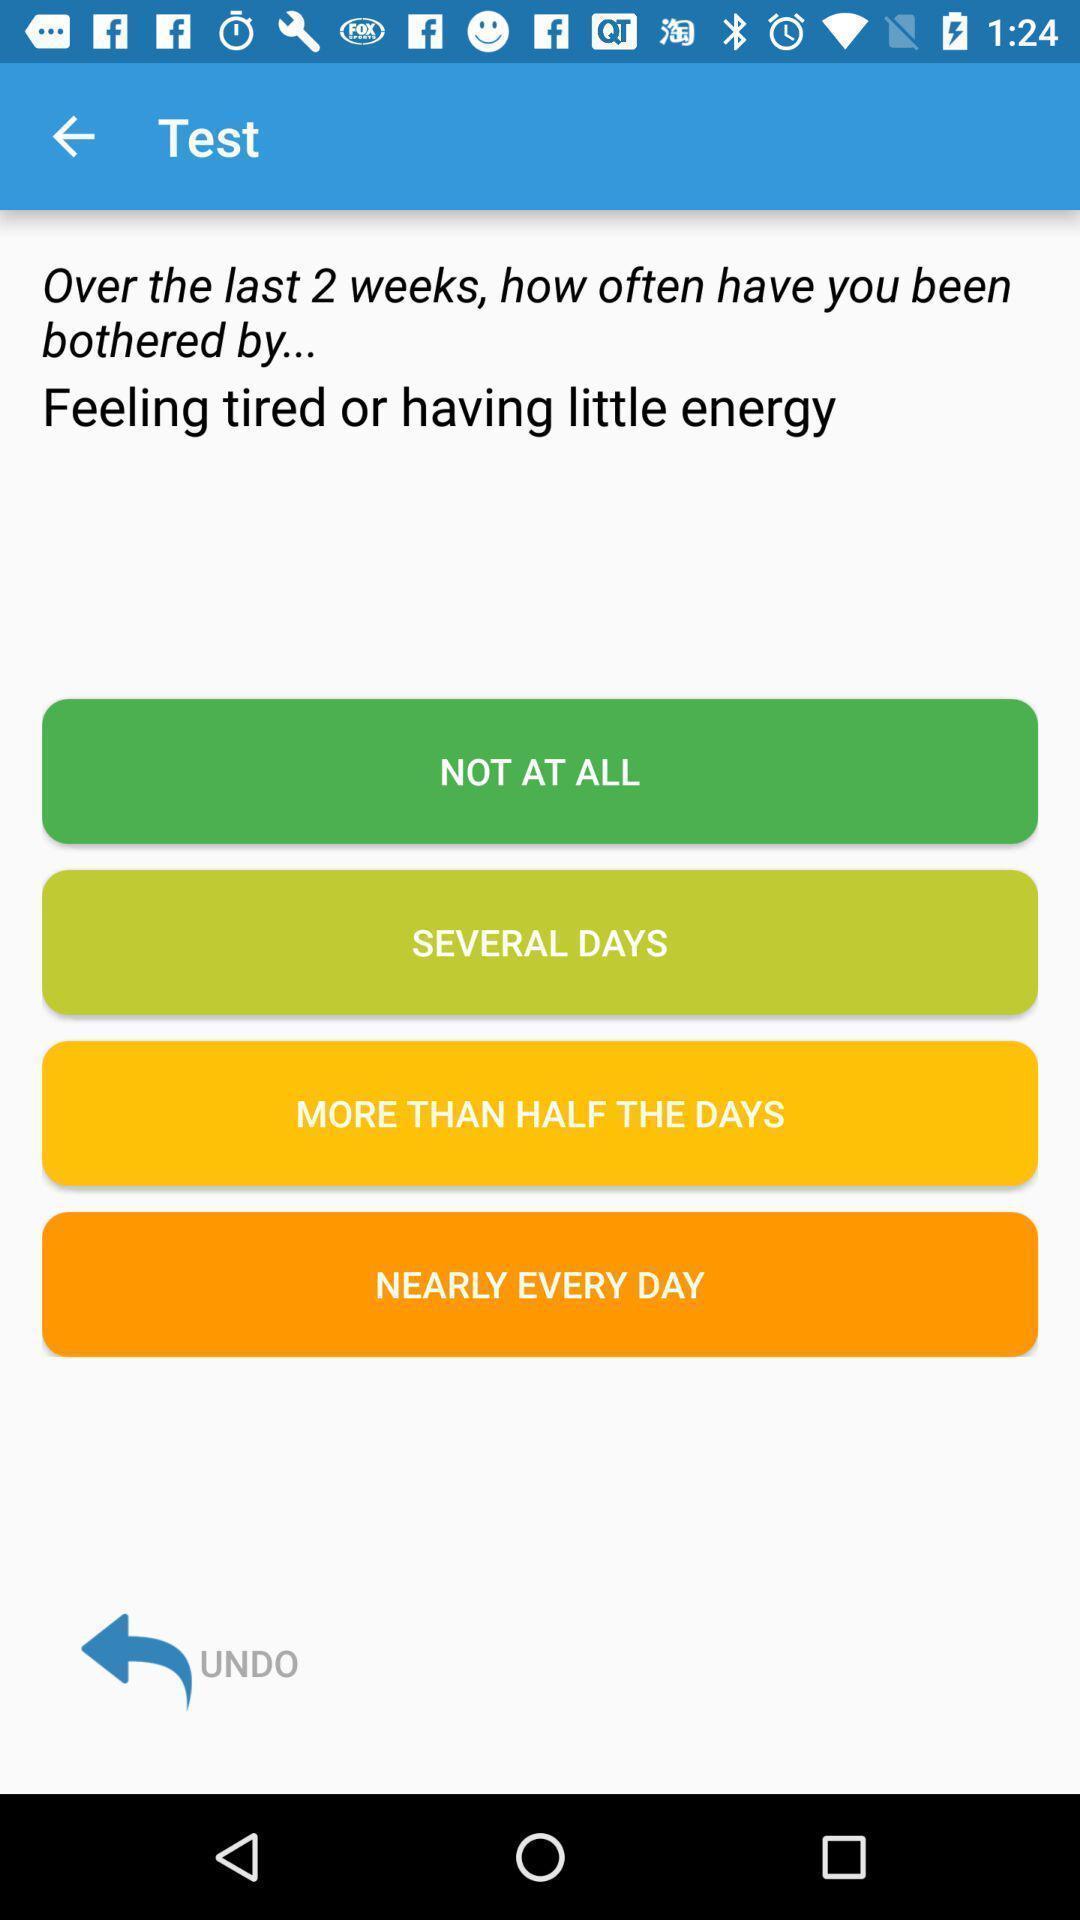Provide a description of this screenshot. Test in the application regarding feelings of the person. 